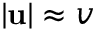<formula> <loc_0><loc_0><loc_500><loc_500>| u | \approx v</formula> 